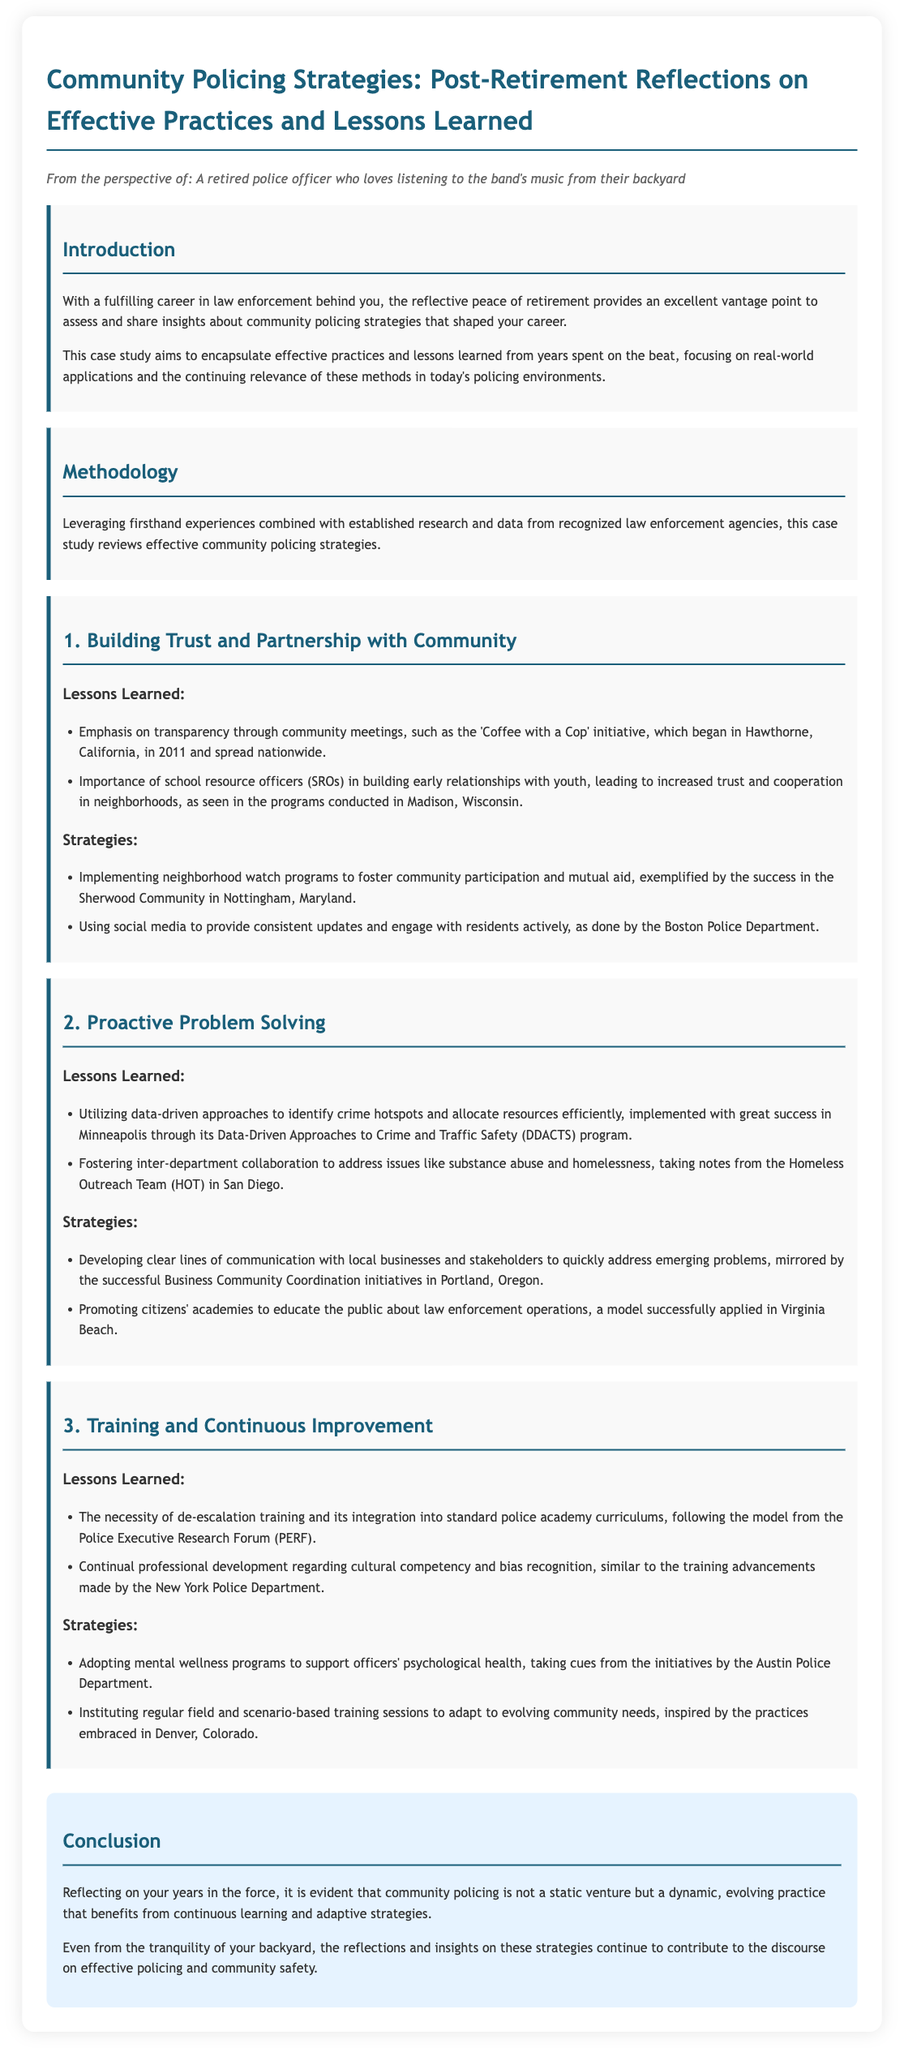What is the title of the case study? The title is stated prominently at the top of the document.
Answer: Community Policing Strategies: Post-Retirement Reflections on Effective Practices and Lessons Learned What initiative began in Hawthorne, California, in 2011? This is mentioned under the section about building trust and partnership with the community.
Answer: 'Coffee with a Cop' How many key topics are covered in the main sections? The document outlines three main sections which can be counted.
Answer: 3 What program in San Diego addresses issues like substance abuse and homelessness? This is specified in the proactive problem-solving section.
Answer: Homeless Outreach Team (HOT) Which department promotes mental wellness programs for officers? The specific police department that implements these programs is mentioned.
Answer: Austin Police Department What is one described strategy to engage with residents actively? The strategy talks about the use of digital platforms for community interaction.
Answer: Social media What educational program is mentioned to improve public understanding of law enforcement? This program is outlined as fostering community education about police operations.
Answer: Citizens' academies According to the document, how is community policing characterized? This phrase summarizes the view on community policing as discussed in the conclusion.
Answer: Dynamic, evolving practice 